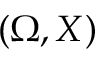Convert formula to latex. <formula><loc_0><loc_0><loc_500><loc_500>( \Omega , X )</formula> 